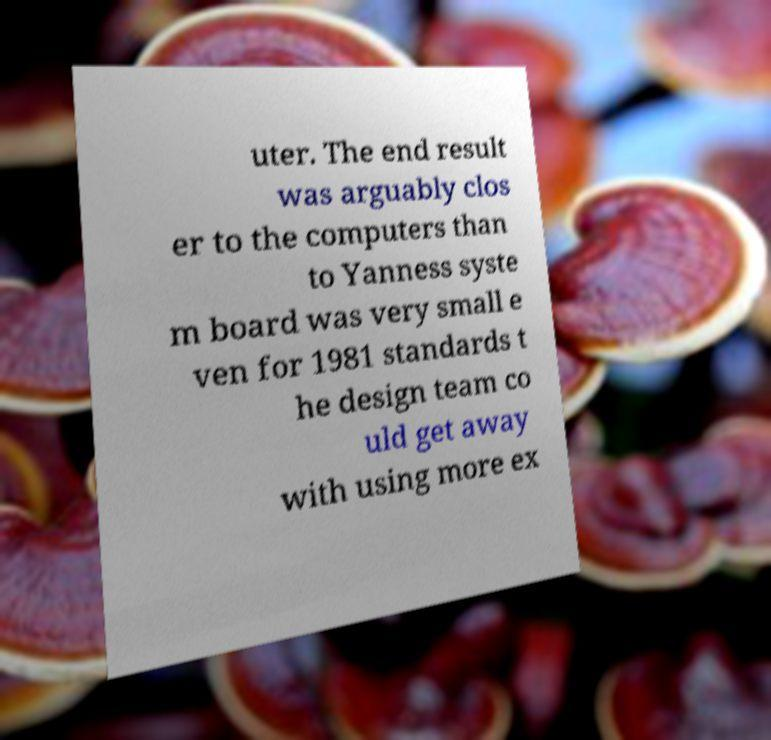There's text embedded in this image that I need extracted. Can you transcribe it verbatim? uter. The end result was arguably clos er to the computers than to Yanness syste m board was very small e ven for 1981 standards t he design team co uld get away with using more ex 